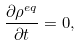<formula> <loc_0><loc_0><loc_500><loc_500>\frac { \partial \rho ^ { e q } } { \partial t } = 0 ,</formula> 